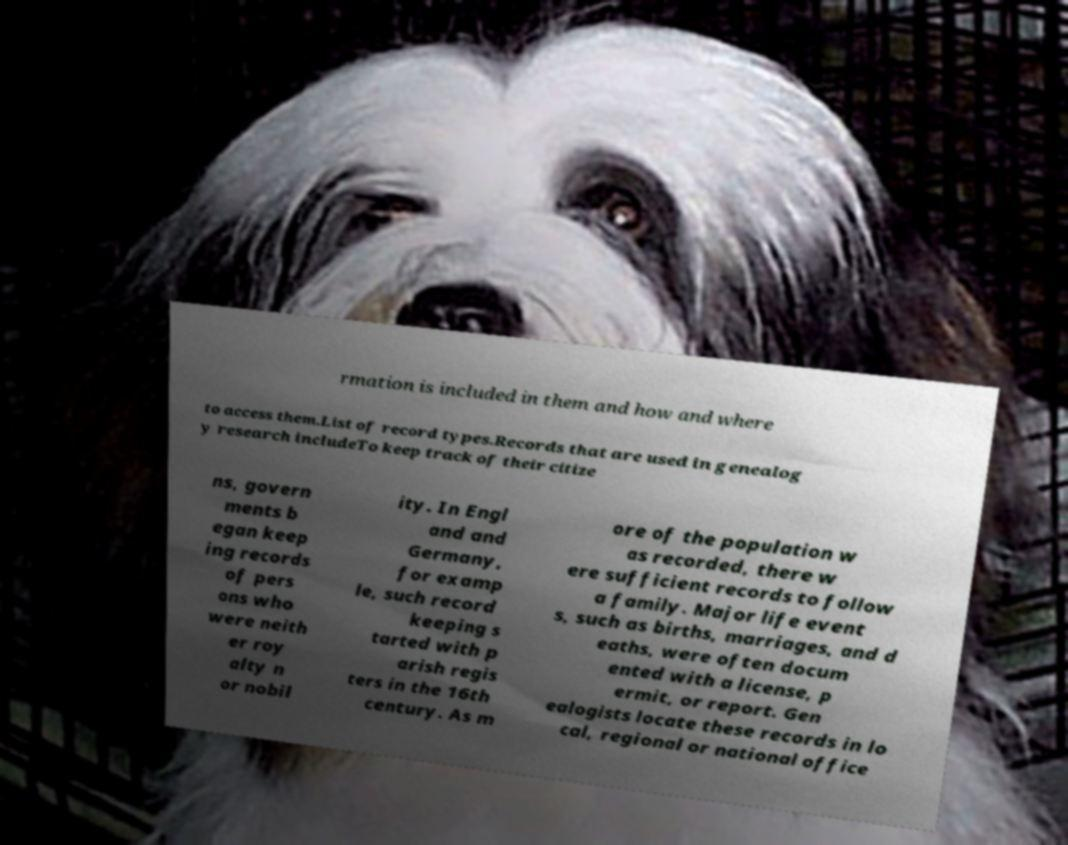I need the written content from this picture converted into text. Can you do that? rmation is included in them and how and where to access them.List of record types.Records that are used in genealog y research includeTo keep track of their citize ns, govern ments b egan keep ing records of pers ons who were neith er roy alty n or nobil ity. In Engl and and Germany, for examp le, such record keeping s tarted with p arish regis ters in the 16th century. As m ore of the population w as recorded, there w ere sufficient records to follow a family. Major life event s, such as births, marriages, and d eaths, were often docum ented with a license, p ermit, or report. Gen ealogists locate these records in lo cal, regional or national office 